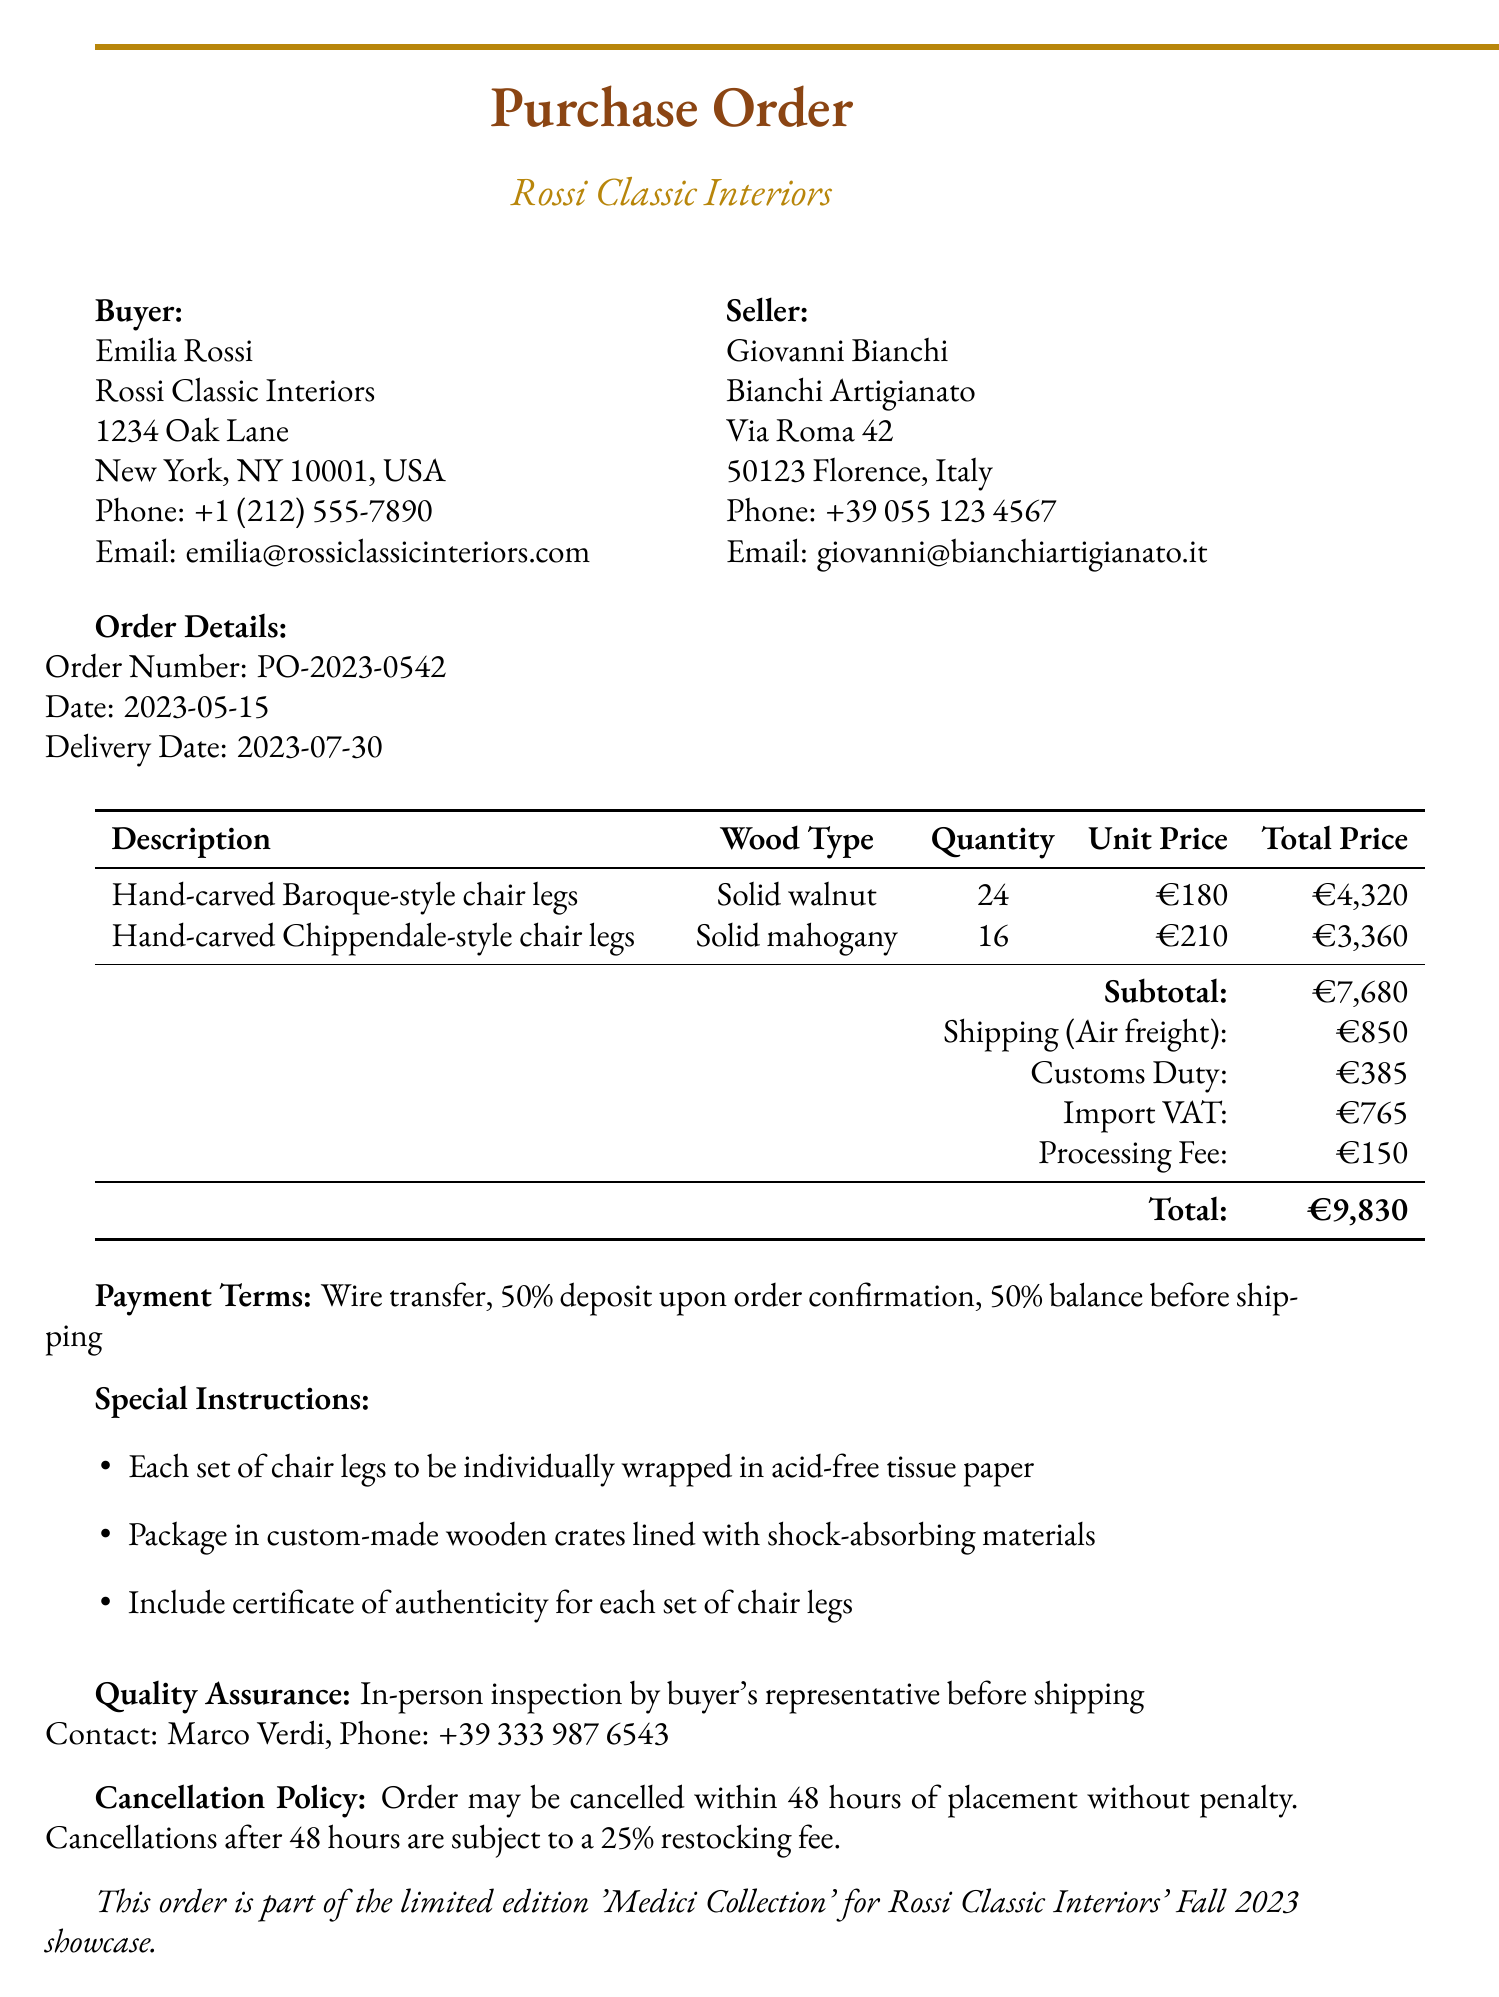What is the order number? The order number is specifically noted in the order details section of the document.
Answer: PO-2023-0542 What is the quantity of hand-carved Chippendale-style chair legs? The quantity for each item is listed in the items section.
Answer: 16 Who is the contact person for quality assurance? The contact person for quality assurance is specified in the quality assurance section of the document.
Answer: Marco Verdi What is the total price for the hand-carved Baroque-style chair legs? The total price is provided alongside the item description in the items section.
Answer: €4,320 What is the shipping method? The shipping method is clearly stated in the shipping section of the document.
Answer: Air freight When is the delivery date? The delivery date is indicated in the order details section of the document.
Answer: 2023-07-30 What is the estimated transit time for shipping? The estimated transit time for shipping is mentioned in the shipping section.
Answer: 5-7 business days What is the cancellation policy? The cancellation policy is outlined specifically in a dedicated section of the document.
Answer: Order may be cancelled within 48 hours of placement without penalty. Cancellations after 48 hours are subject to a 25% restocking fee 